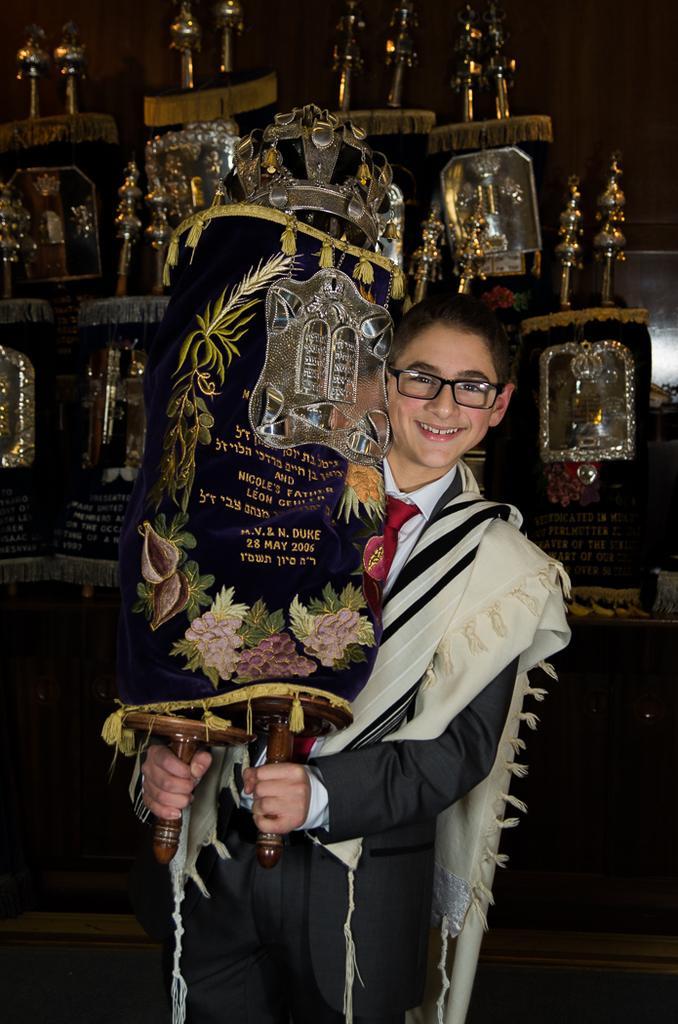How would you summarize this image in a sentence or two? In this picture there is a boy in the center of the image, by holding a trophy in his hands and there are other trophies in the background area of the image. 